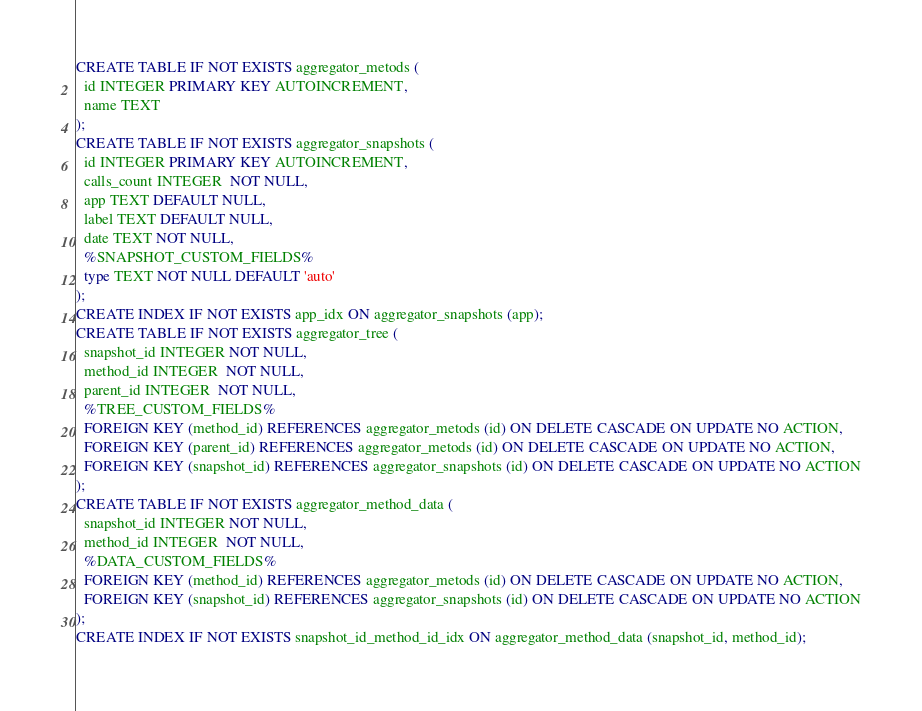<code> <loc_0><loc_0><loc_500><loc_500><_SQL_>CREATE TABLE IF NOT EXISTS aggregator_metods (
  id INTEGER PRIMARY KEY AUTOINCREMENT,
  name TEXT
);
CREATE TABLE IF NOT EXISTS aggregator_snapshots (
  id INTEGER PRIMARY KEY AUTOINCREMENT,
  calls_count INTEGER  NOT NULL,
  app TEXT DEFAULT NULL,
  label TEXT DEFAULT NULL,
  date TEXT NOT NULL,
  %SNAPSHOT_CUSTOM_FIELDS%
  type TEXT NOT NULL DEFAULT 'auto'
);
CREATE INDEX IF NOT EXISTS app_idx ON aggregator_snapshots (app);
CREATE TABLE IF NOT EXISTS aggregator_tree (
  snapshot_id INTEGER NOT NULL,
  method_id INTEGER  NOT NULL,
  parent_id INTEGER  NOT NULL,
  %TREE_CUSTOM_FIELDS%
  FOREIGN KEY (method_id) REFERENCES aggregator_metods (id) ON DELETE CASCADE ON UPDATE NO ACTION,
  FOREIGN KEY (parent_id) REFERENCES aggregator_metods (id) ON DELETE CASCADE ON UPDATE NO ACTION,
  FOREIGN KEY (snapshot_id) REFERENCES aggregator_snapshots (id) ON DELETE CASCADE ON UPDATE NO ACTION
);
CREATE TABLE IF NOT EXISTS aggregator_method_data (
  snapshot_id INTEGER NOT NULL,
  method_id INTEGER  NOT NULL,
  %DATA_CUSTOM_FIELDS%
  FOREIGN KEY (method_id) REFERENCES aggregator_metods (id) ON DELETE CASCADE ON UPDATE NO ACTION,
  FOREIGN KEY (snapshot_id) REFERENCES aggregator_snapshots (id) ON DELETE CASCADE ON UPDATE NO ACTION
);
CREATE INDEX IF NOT EXISTS snapshot_id_method_id_idx ON aggregator_method_data (snapshot_id, method_id);
</code> 